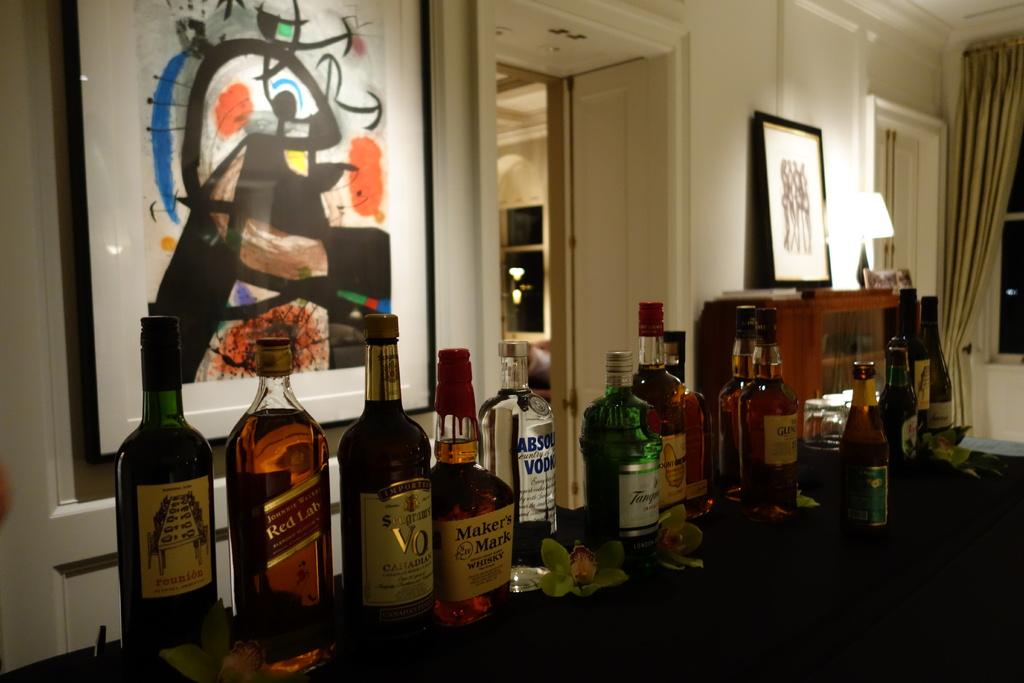What brand of whiskey is on the table?
Provide a short and direct response. Maker's mark. What brand is displayed on the bottle second from the left?
Your answer should be very brief. Red label. 